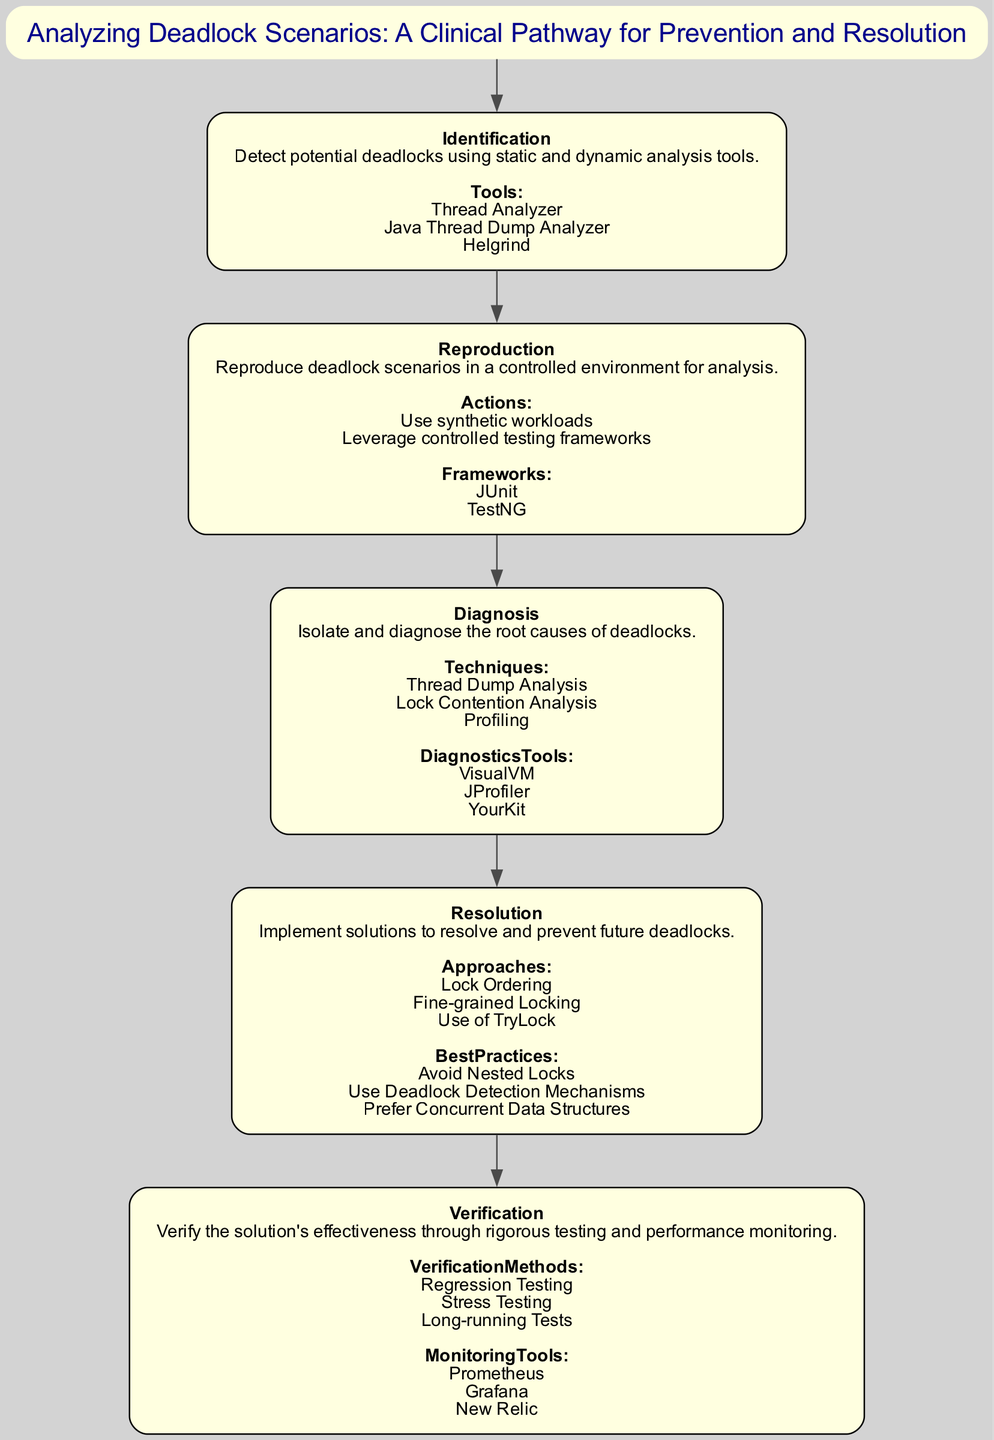What is the title of the clinical pathway? The title can be found at the top of the diagram, identified as "Clinical Pathway". It provides a brief overview of the main focus, in this case, "Analyzing Deadlock Scenarios: A Clinical Pathway for Prevention and Resolution".
Answer: Analyzing Deadlock Scenarios: A Clinical Pathway for Prevention and Resolution How many steps are there in the pathway? By counting the steps listed in the diagram from "Identification" to "Verification", we can see that there are a total of five distinct steps in the clinical pathway.
Answer: 5 What is the first step in the pathway? The first step is indicated at the top of the flow diagram, and it is titled "Identification," which clearly denotes the beginning of the clinical pathway.
Answer: Identification What tools are listed under the "Identification" step? Referring to the details under the "Identification" node in the diagram, we see three tools mentioned: "Thread Analyzer," "Java Thread Dump Analyzer," and "Helgrind".
Answer: Thread Analyzer, Java Thread Dump Analyzer, Helgrind Which step involves "Lock Ordering"? We look through the steps in the pathway, and "Lock Ordering" is specified as an approach under the "Resolution" step. This indicates that it is part of the methods used to resolve deadlocks.
Answer: Resolution What are the verification methods listed in the final step? Reviewing the final step, which is "Verification," we find three listed methods: "Regression Testing," "Stress Testing," and "Long-running Tests". These are the techniques used to verify the effectiveness of the solution.
Answer: Regression Testing, Stress Testing, Long-running Tests Which diagnostic tool is used for analyzing deadlocks? Under the "Diagnosis" step, it mentions three diagnostic tools: "VisualVM," "JProfiler," and "YourKit," indicating they are used for the analysis of deadlocks.
Answer: VisualVM, JProfiler, YourKit What is one best practice mentioned under the "Resolution" step? In reviewing the practices highlighted under "Resolution," "Avoid Nested Locks" is one of the recommended best practices to prevent future deadlocks.
Answer: Avoid Nested Locks What is the last step in the clinical pathway? The last step in the flow of the clinical pathway is labeled as "Verification", indicating it is the concluding action after implementing the solutions.
Answer: Verification 